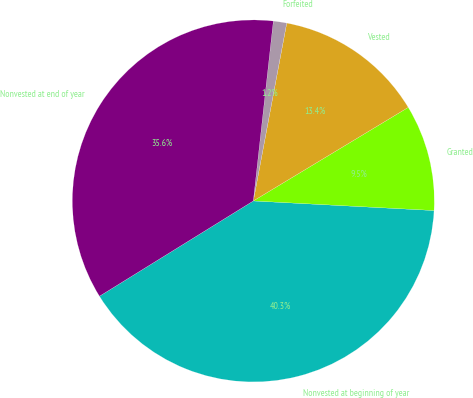Convert chart. <chart><loc_0><loc_0><loc_500><loc_500><pie_chart><fcel>Nonvested at beginning of year<fcel>Granted<fcel>Vested<fcel>Forfeited<fcel>Nonvested at end of year<nl><fcel>40.33%<fcel>9.49%<fcel>13.4%<fcel>1.19%<fcel>35.59%<nl></chart> 